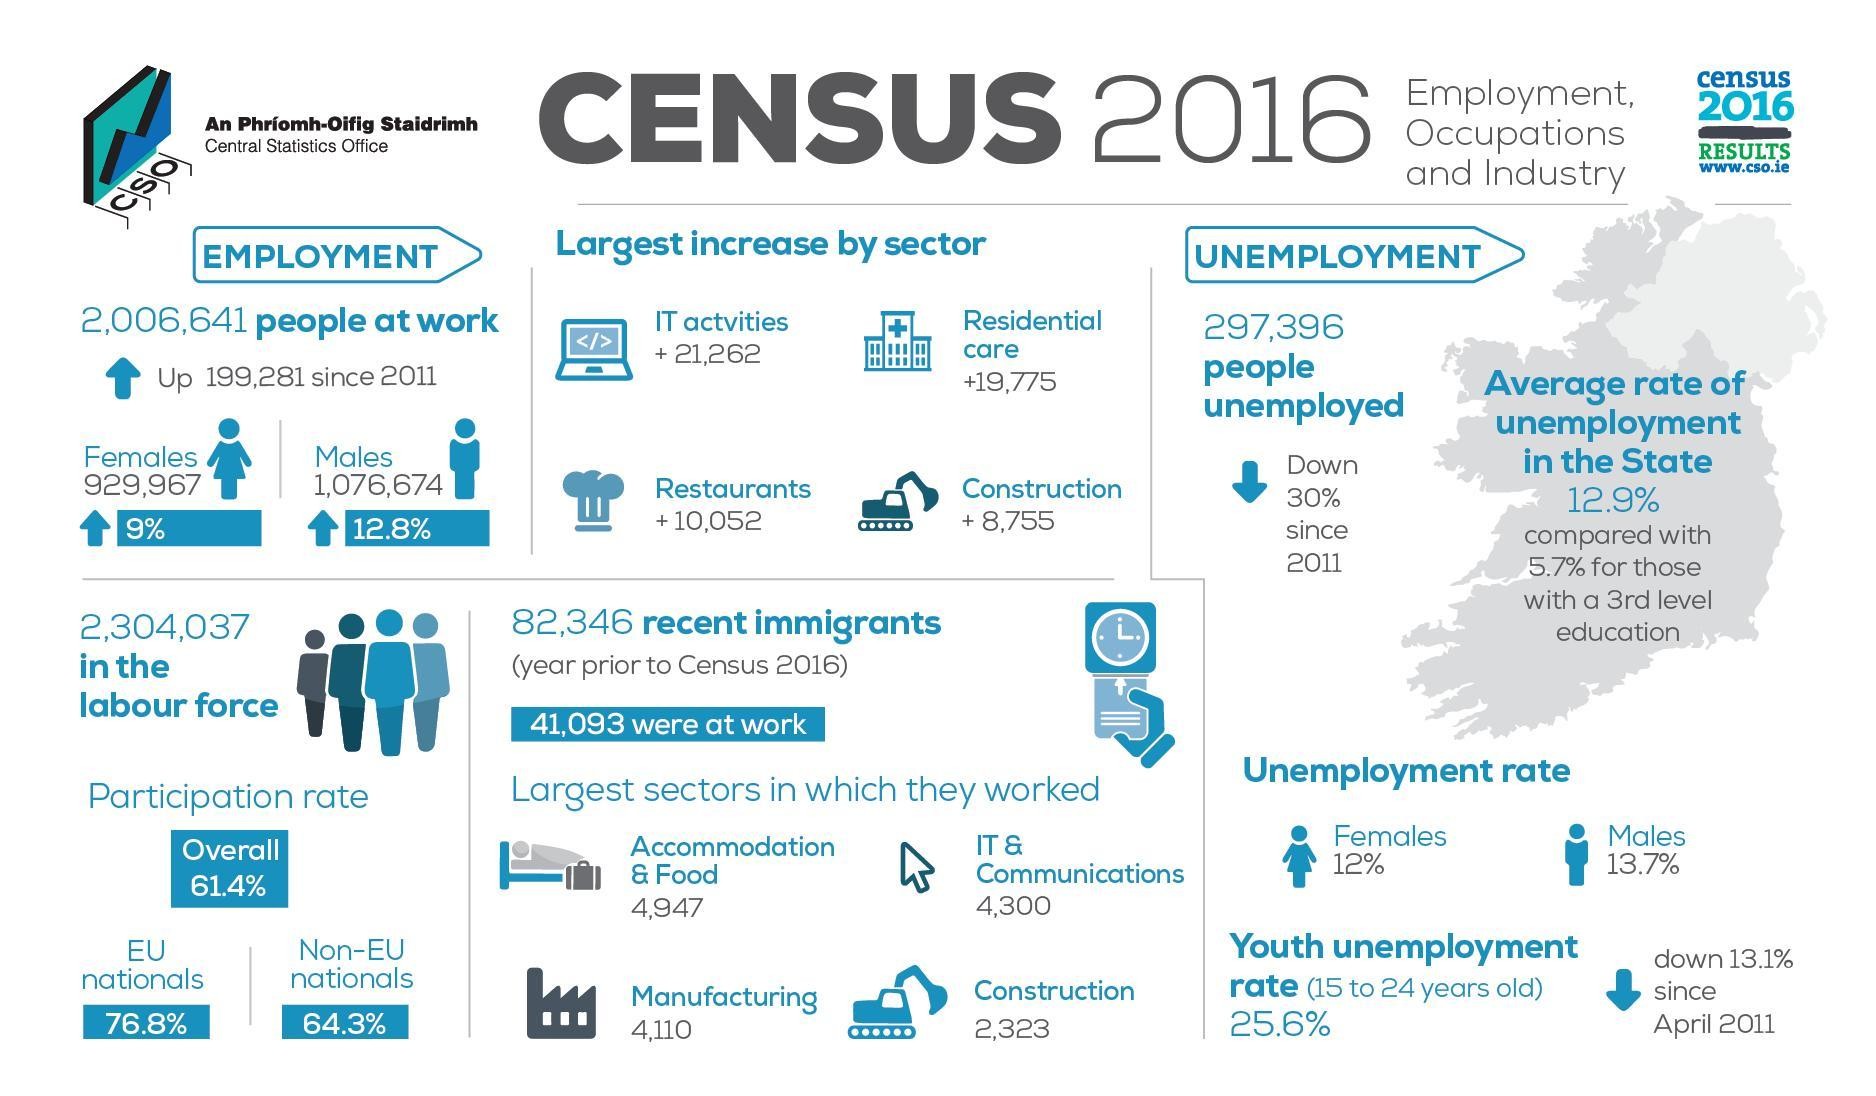What is the percentage increase in male at work in Ireland as per the CSO census 2016?
Answer the question with a short phrase. 12.8% What is the increase in the number of restaurants in Ireland as per the CSO census 2016? 10,052 What is the participation rate of EU nationals in the labour force in Ireland as per the CSO census 2016? 76.8% What percent of the unemployed are females in Ireland as per the CSO census 2016? 12% What is the increase in the number of residential care in Ireland as per the CSO census 2016? 19,775 How many people were unemployed in Ireland as per the CSO census 2016? 297,396 What is the percentage increase in female at work in Ireland as per the CSO census 2016? 9% How many immigrants have worked in the construction sector in Ireland as per the CSO census 2016? 2,323 How many immigrants have worked in the manufacturing industry in Ireland as per the CSO census 2016? 4,110 What is the participation rate of non-EU nationals in the labour force in Ireland as per the CSO census 2016? 64.3% 